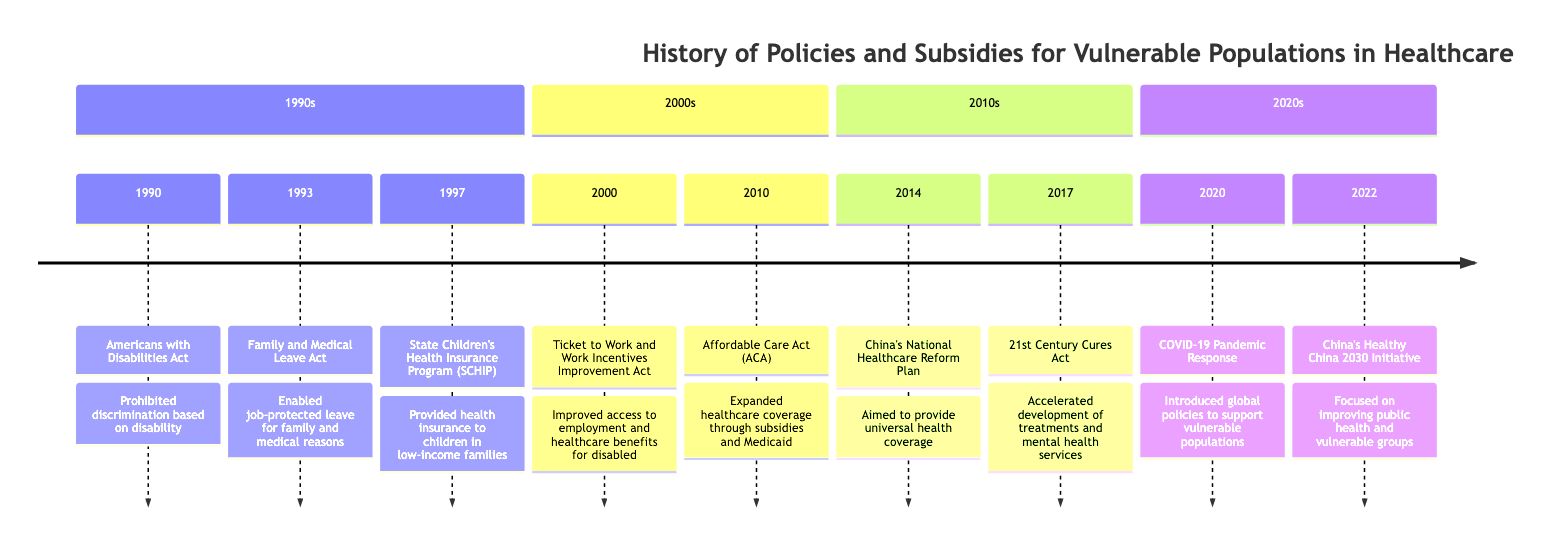What landmark law was enacted in 1990? The diagram shows that the event in 1990 is the "Americans with Disabilities Act." This is clearly labeled as a significant event and represents a key historical milestone.
Answer: Americans with Disabilities Act What program was introduced in 1997 to help children? Referring to the section for the 1990s, the event listed for 1997 is the "State Children's Health Insurance Program (SCHIP)." This term signifies a program aimed at assisting children from low-income families.
Answer: State Children's Health Insurance Program (SCHIP) How many events are there in the 2000s section? The diagram lists three events in the 2000s section: "Ticket to Work and Work Incentives Improvement Act" in 2000 and "Affordable Care Act (ACA)" in 2010. Thus, by counting these, there are two events.
Answer: 2 Which act focused on universal health coverage in China in 2014? The 2014 event labeled in the diagram is "China's National Healthcare Reform Plan," which is focused on universal health coverage as described in the event's description.
Answer: China's National Healthcare Reform Plan What was a key focus of the 2022 initiative in China? The 2022 event titled "China's Healthy China 2030 Initiative" in the timeline specifically mentions a focus on improving public health, which directly relates to vulnerable groups needing better healthcare access.
Answer: Improving public health Which act accelerated mental health treatment development in 2017? The answer to this is found in the 2017 event listed as "21st Century Cures Act," which is explicitly described as accelerating the development of treatment and mental health services.
Answer: 21st Century Cures Act What significant healthcare legislation was passed in 2010? Looking at the 2010 section, the legislation in question is the "Affordable Care Act (ACA)," which is the significant healthcare reform passed that year aimed at expanding healthcare coverage.
Answer: Affordable Care Act (ACA) What year did the COVID-19 Pandemic Response occur within the timeline? The diagram states that the event named "COVID-19 Pandemic Response" occurred in the year 2020, which is directly mentioned in the timeline.
Answer: 2020 How did the Americans with Disabilities Act impact healthcare access? The diagram indicates that the Americans with Disabilities Act prohibited discrimination based on disability, which directly enhances healthcare access for vulnerable populations.
Answer: Enhanced access 